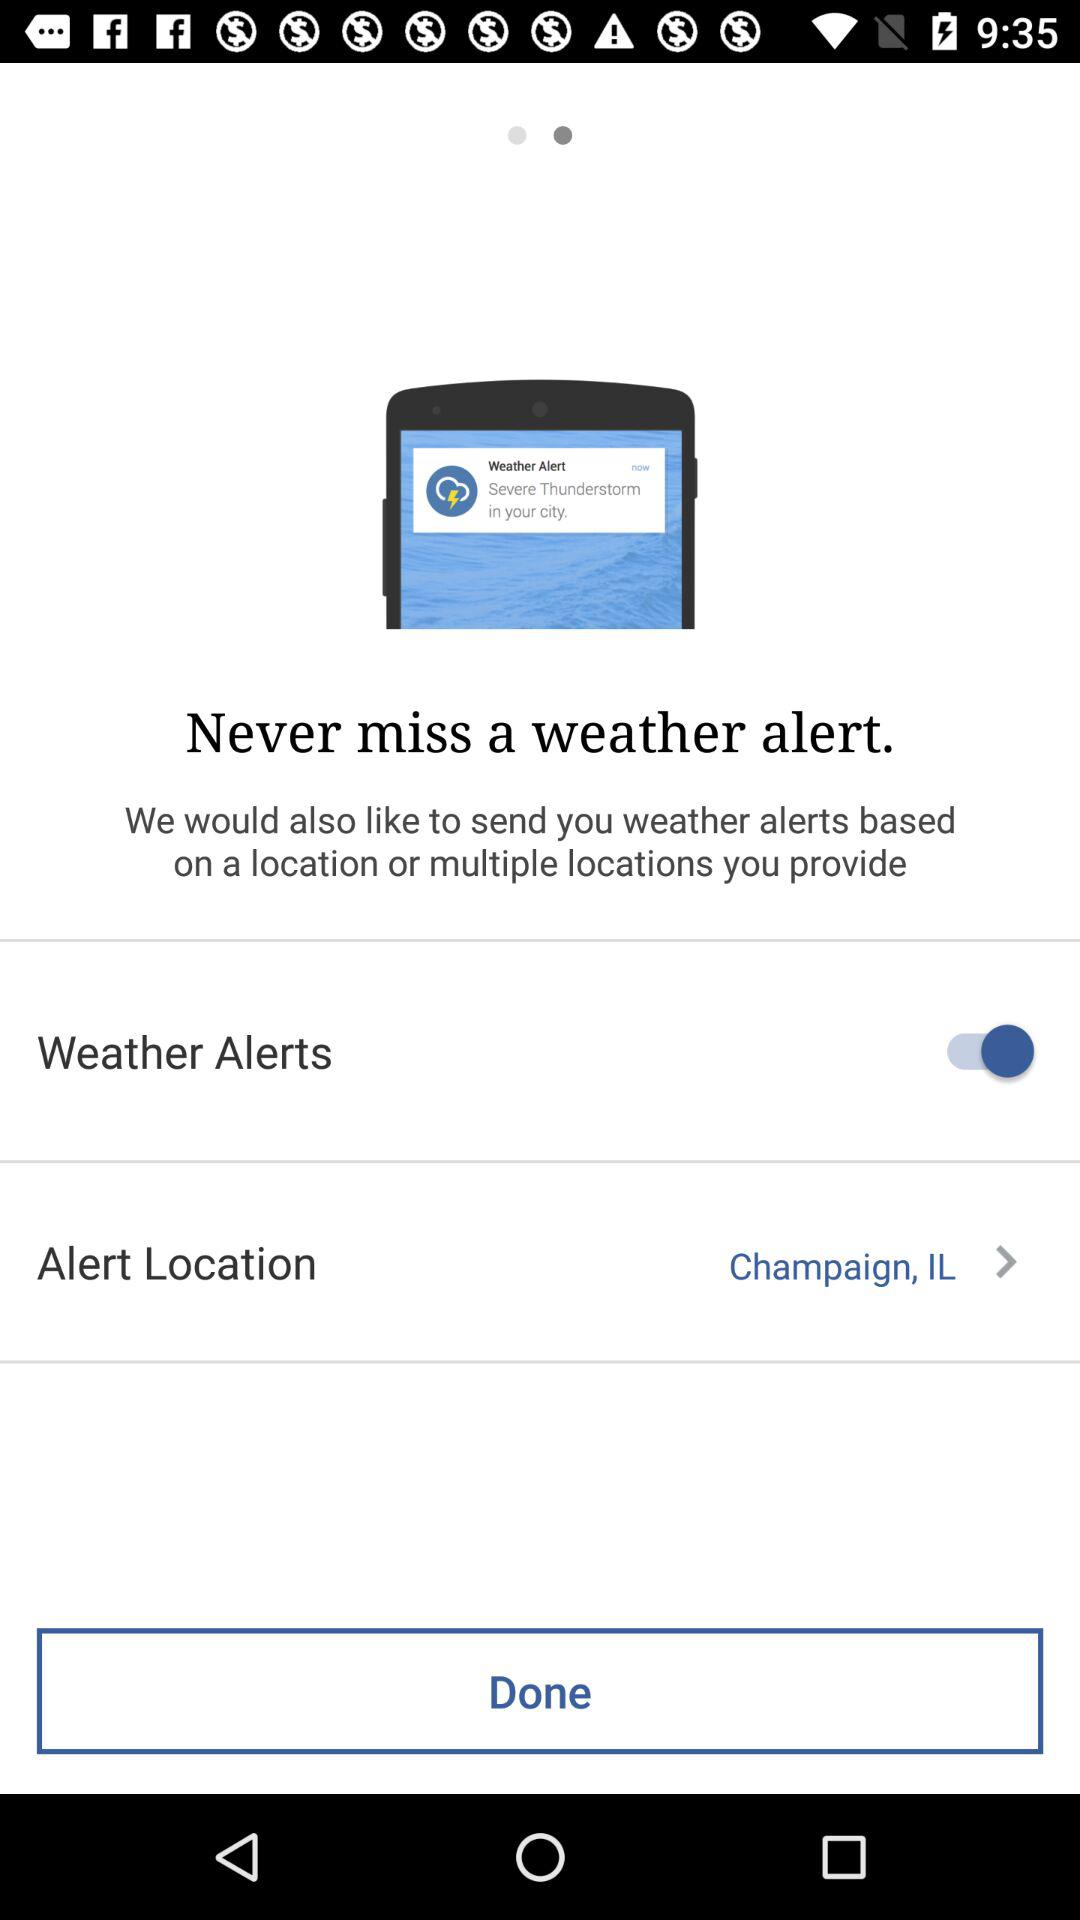How many options are there to customize the weather alerts?
Answer the question using a single word or phrase. 2 